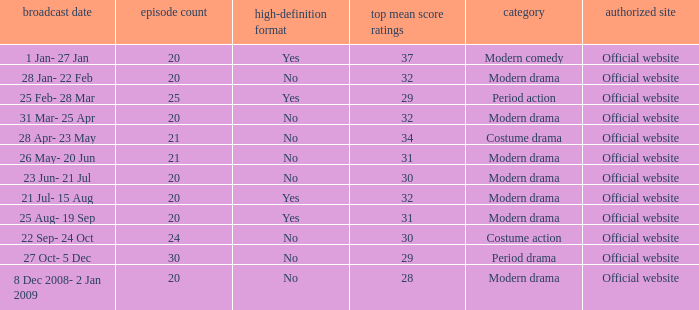What are the number of episodes when the genre is modern drama and the highest average ratings points are 28? 20.0. 